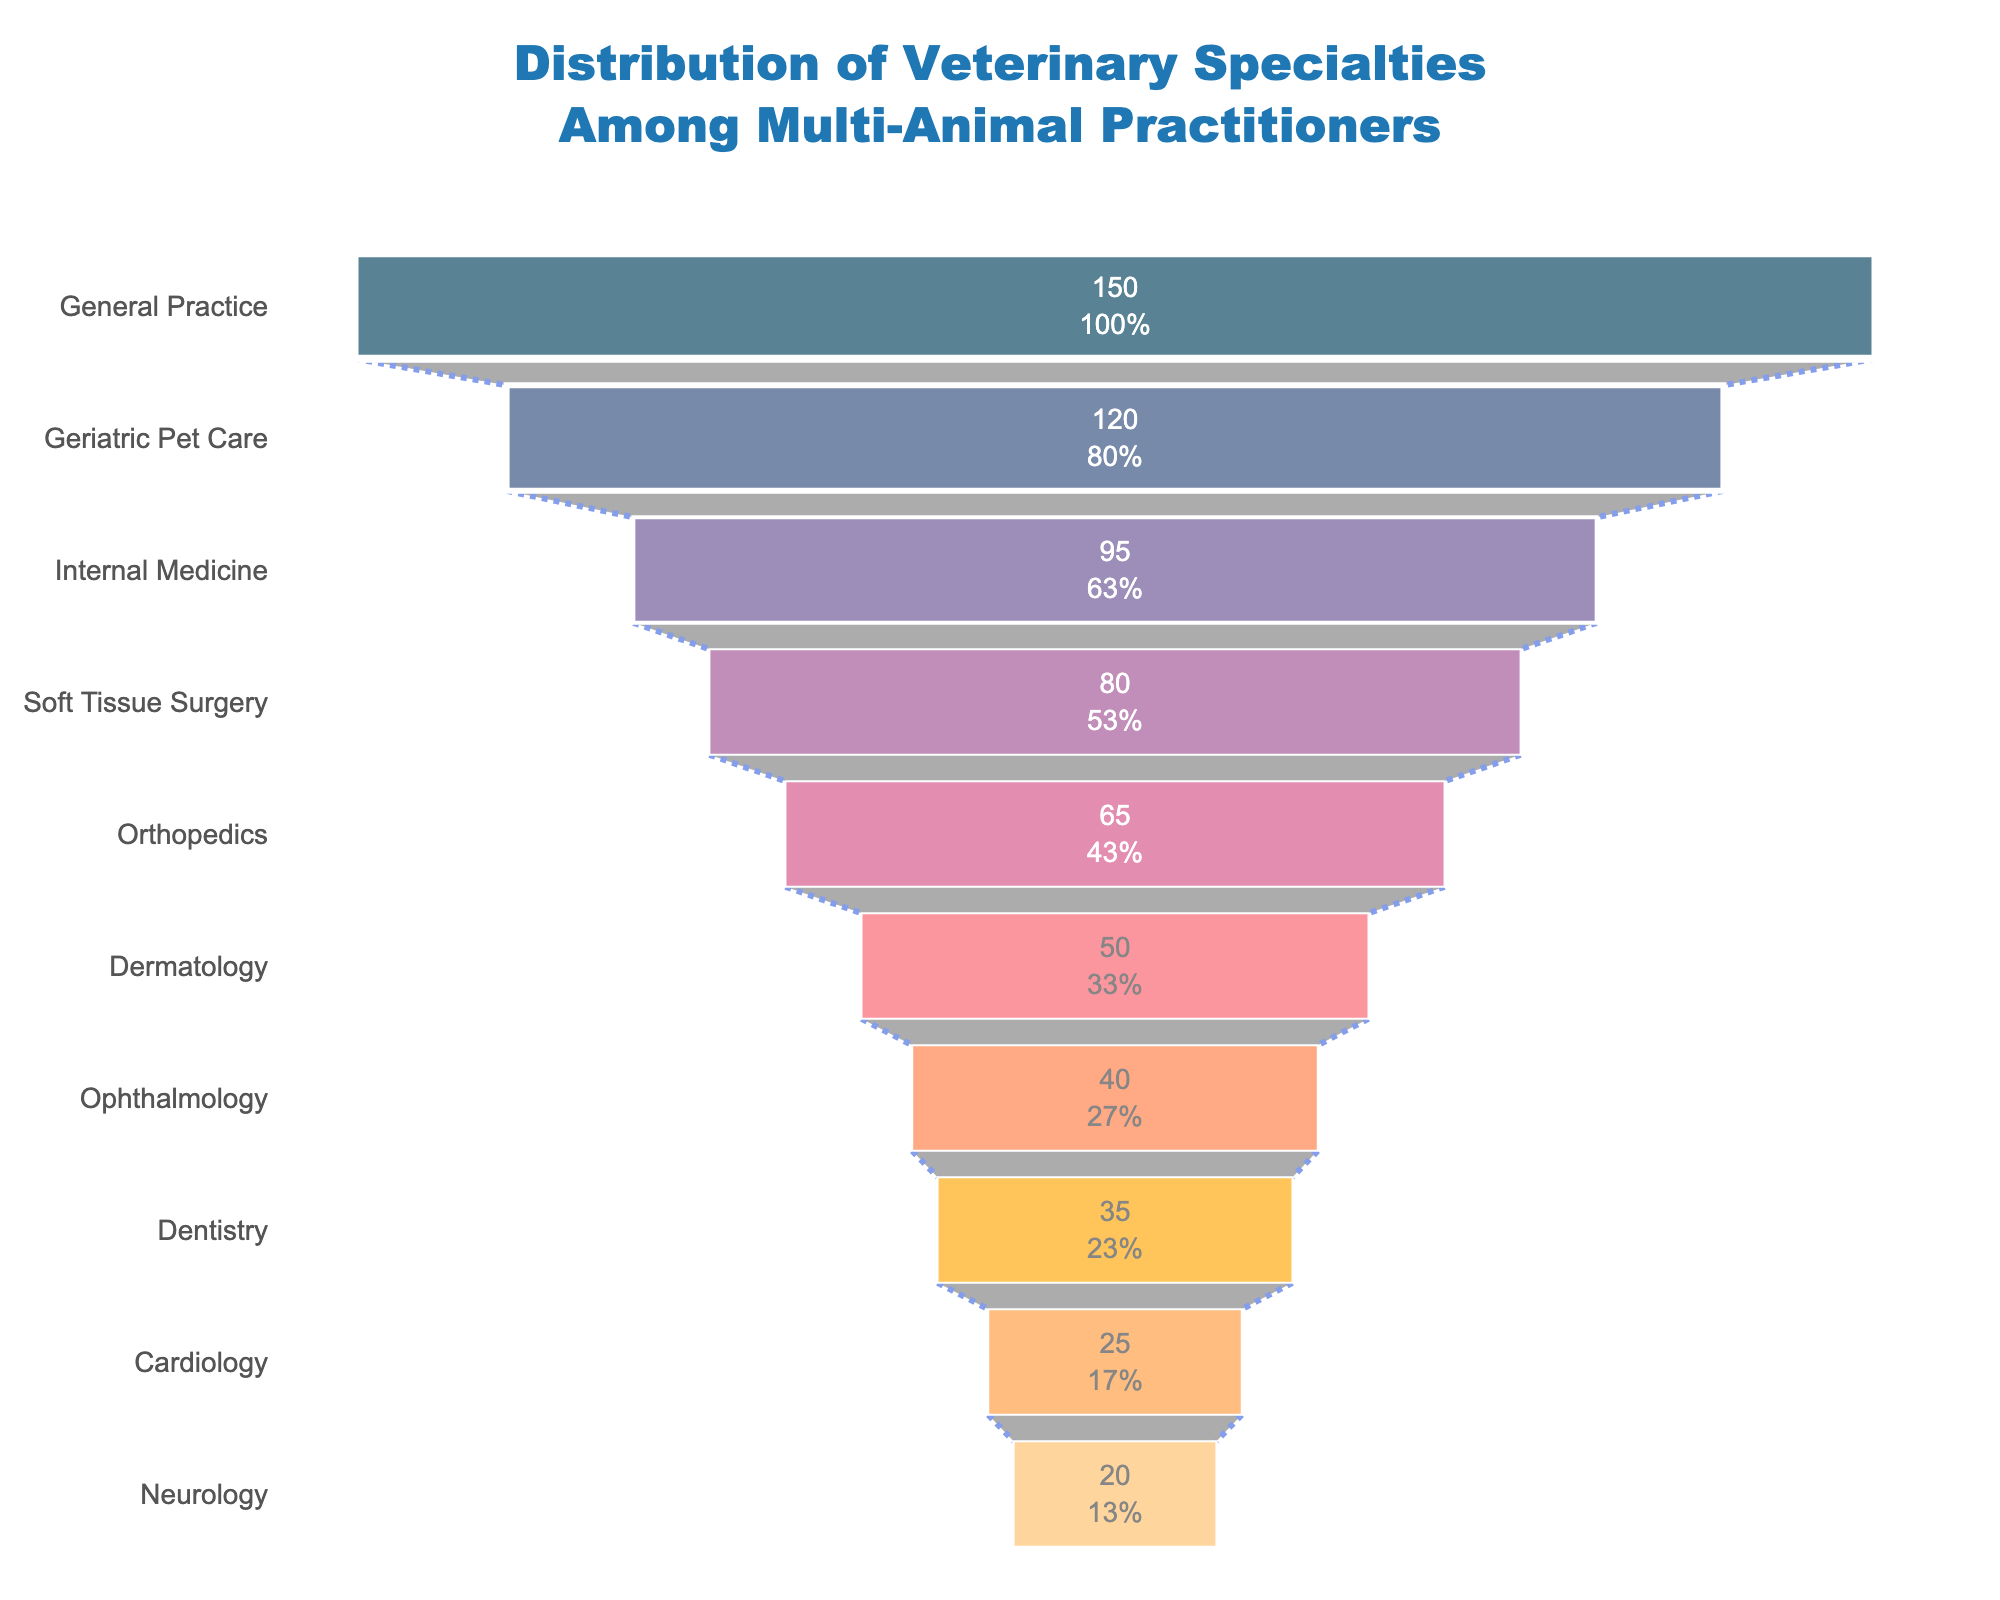What's the title of the funnel chart? The title is displayed at the top of the chart, stating the main topic it represents.
Answer: Distribution of Veterinary Specialties Among Multi-Animal Practitioners What specialty has the highest number of practitioners? The specialty at the widest part of the funnel represents the one with the highest number of practitioners.
Answer: General Practice How many practitioners specialize in Cardiology? The value inside the section labeled "Cardiology" represents the number of practitioners for this specialty.
Answer: 25 What's the difference in the number of practitioners between General Practice and Dermatology? Subtract the number of practitioners in Dermatology from those in General Practice (150 - 50).
Answer: 100 What percent of the initial practitioners specialize in Internal Medicine? The percent value inside the section labeled "Internal Medicine" provides this information.
Answer: 17% Which is more common, Ophthalmology or Dentistry specializations? Compare the number of practitioners for Ophthalmology (40) and Dentistry (35).
Answer: Ophthalmology How many specialties have at least 50 practitioners? Count the specialties on the chart whose values are 50 or more.
Answer: 6 What is the combined number of practitioners for Soft Tissue Surgery and Orthopedics? Add the number of practitioners in Soft Tissue Surgery (80) and Orthopedics (65).
Answer: 145 Is Geriatric Pet Care more popular than Internal Medicine? Compare the values for Geriatric Pet Care (120) and Internal Medicine (95).
Answer: Yes What specialty has the fewest practitioners? The specialty at the narrowest part of the funnel represents the one with the fewest practitioners.
Answer: Neurology 